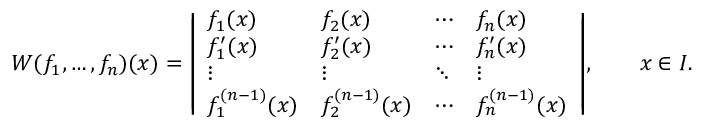<formula> <loc_0><loc_0><loc_500><loc_500>W ( f _ { 1 } , \dots , f _ { n } ) ( x ) = { \left | \begin{array} { l l l l } { f _ { 1 } ( x ) } & { f _ { 2 } ( x ) } & { \cdots } & { f _ { n } ( x ) } \\ { f _ { 1 } ^ { \prime } ( x ) } & { f _ { 2 } ^ { \prime } ( x ) } & { \cdots } & { f _ { n } ^ { \prime } ( x ) } \\ { \vdots } & { \vdots } & { \ddots } & { \vdots } \\ { f _ { 1 } ^ { ( n - 1 ) } ( x ) } & { f _ { 2 } ^ { ( n - 1 ) } ( x ) } & { \cdots } & { f _ { n } ^ { ( n - 1 ) } ( x ) } \end{array} \right | } , \quad x \in I .</formula> 